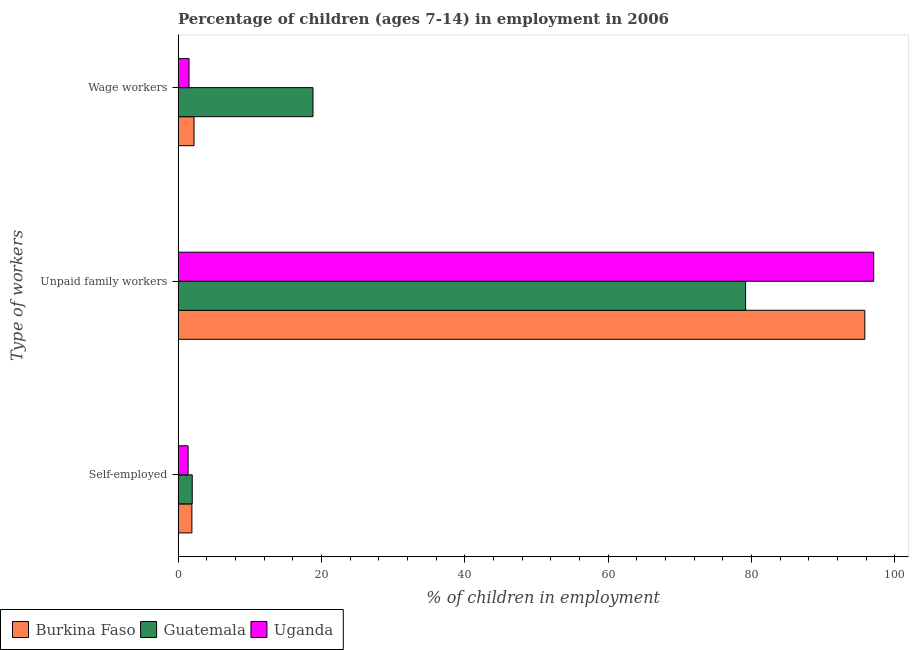How many different coloured bars are there?
Keep it short and to the point. 3. How many groups of bars are there?
Ensure brevity in your answer.  3. Are the number of bars per tick equal to the number of legend labels?
Your answer should be very brief. Yes. Are the number of bars on each tick of the Y-axis equal?
Your answer should be very brief. Yes. How many bars are there on the 2nd tick from the top?
Provide a succinct answer. 3. What is the label of the 1st group of bars from the top?
Give a very brief answer. Wage workers. What is the percentage of children employed as unpaid family workers in Uganda?
Ensure brevity in your answer.  97.07. Across all countries, what is the maximum percentage of children employed as unpaid family workers?
Give a very brief answer. 97.07. Across all countries, what is the minimum percentage of children employed as wage workers?
Provide a short and direct response. 1.53. In which country was the percentage of children employed as unpaid family workers maximum?
Offer a very short reply. Uganda. In which country was the percentage of children employed as unpaid family workers minimum?
Provide a succinct answer. Guatemala. What is the total percentage of children employed as unpaid family workers in the graph?
Make the answer very short. 272.09. What is the difference between the percentage of children employed as wage workers in Burkina Faso and that in Guatemala?
Your answer should be compact. -16.6. What is the difference between the percentage of self employed children in Uganda and the percentage of children employed as wage workers in Guatemala?
Offer a terse response. -17.43. What is the average percentage of self employed children per country?
Make the answer very short. 1.77. What is the difference between the percentage of self employed children and percentage of children employed as unpaid family workers in Uganda?
Keep it short and to the point. -95.67. What is the ratio of the percentage of children employed as wage workers in Burkina Faso to that in Guatemala?
Your response must be concise. 0.12. Is the percentage of self employed children in Uganda less than that in Guatemala?
Your answer should be very brief. Yes. What is the difference between the highest and the second highest percentage of self employed children?
Offer a very short reply. 0.05. What is the difference between the highest and the lowest percentage of children employed as wage workers?
Offer a very short reply. 17.3. In how many countries, is the percentage of self employed children greater than the average percentage of self employed children taken over all countries?
Your response must be concise. 2. Is the sum of the percentage of children employed as unpaid family workers in Uganda and Guatemala greater than the maximum percentage of self employed children across all countries?
Your answer should be very brief. Yes. What does the 3rd bar from the top in Unpaid family workers represents?
Offer a terse response. Burkina Faso. What does the 2nd bar from the bottom in Wage workers represents?
Your answer should be compact. Guatemala. How many bars are there?
Give a very brief answer. 9. Are all the bars in the graph horizontal?
Your answer should be very brief. Yes. How many countries are there in the graph?
Your response must be concise. 3. Does the graph contain any zero values?
Your answer should be compact. No. Does the graph contain grids?
Offer a very short reply. No. What is the title of the graph?
Ensure brevity in your answer.  Percentage of children (ages 7-14) in employment in 2006. Does "Niger" appear as one of the legend labels in the graph?
Your response must be concise. No. What is the label or title of the X-axis?
Make the answer very short. % of children in employment. What is the label or title of the Y-axis?
Provide a succinct answer. Type of workers. What is the % of children in employment in Burkina Faso in Self-employed?
Ensure brevity in your answer.  1.93. What is the % of children in employment in Guatemala in Self-employed?
Offer a very short reply. 1.98. What is the % of children in employment in Uganda in Self-employed?
Keep it short and to the point. 1.4. What is the % of children in employment in Burkina Faso in Unpaid family workers?
Your answer should be compact. 95.83. What is the % of children in employment of Guatemala in Unpaid family workers?
Your answer should be very brief. 79.19. What is the % of children in employment in Uganda in Unpaid family workers?
Make the answer very short. 97.07. What is the % of children in employment of Burkina Faso in Wage workers?
Your response must be concise. 2.23. What is the % of children in employment of Guatemala in Wage workers?
Your answer should be compact. 18.83. What is the % of children in employment in Uganda in Wage workers?
Your answer should be compact. 1.53. Across all Type of workers, what is the maximum % of children in employment of Burkina Faso?
Give a very brief answer. 95.83. Across all Type of workers, what is the maximum % of children in employment in Guatemala?
Your response must be concise. 79.19. Across all Type of workers, what is the maximum % of children in employment in Uganda?
Ensure brevity in your answer.  97.07. Across all Type of workers, what is the minimum % of children in employment in Burkina Faso?
Keep it short and to the point. 1.93. Across all Type of workers, what is the minimum % of children in employment of Guatemala?
Provide a succinct answer. 1.98. What is the total % of children in employment in Burkina Faso in the graph?
Give a very brief answer. 99.99. What is the total % of children in employment of Uganda in the graph?
Keep it short and to the point. 100. What is the difference between the % of children in employment of Burkina Faso in Self-employed and that in Unpaid family workers?
Provide a short and direct response. -93.9. What is the difference between the % of children in employment of Guatemala in Self-employed and that in Unpaid family workers?
Provide a succinct answer. -77.21. What is the difference between the % of children in employment of Uganda in Self-employed and that in Unpaid family workers?
Provide a short and direct response. -95.67. What is the difference between the % of children in employment in Burkina Faso in Self-employed and that in Wage workers?
Provide a succinct answer. -0.3. What is the difference between the % of children in employment of Guatemala in Self-employed and that in Wage workers?
Provide a succinct answer. -16.85. What is the difference between the % of children in employment in Uganda in Self-employed and that in Wage workers?
Provide a short and direct response. -0.13. What is the difference between the % of children in employment in Burkina Faso in Unpaid family workers and that in Wage workers?
Make the answer very short. 93.6. What is the difference between the % of children in employment of Guatemala in Unpaid family workers and that in Wage workers?
Give a very brief answer. 60.36. What is the difference between the % of children in employment of Uganda in Unpaid family workers and that in Wage workers?
Your response must be concise. 95.54. What is the difference between the % of children in employment of Burkina Faso in Self-employed and the % of children in employment of Guatemala in Unpaid family workers?
Ensure brevity in your answer.  -77.26. What is the difference between the % of children in employment in Burkina Faso in Self-employed and the % of children in employment in Uganda in Unpaid family workers?
Your answer should be very brief. -95.14. What is the difference between the % of children in employment in Guatemala in Self-employed and the % of children in employment in Uganda in Unpaid family workers?
Provide a succinct answer. -95.09. What is the difference between the % of children in employment of Burkina Faso in Self-employed and the % of children in employment of Guatemala in Wage workers?
Ensure brevity in your answer.  -16.9. What is the difference between the % of children in employment of Guatemala in Self-employed and the % of children in employment of Uganda in Wage workers?
Give a very brief answer. 0.45. What is the difference between the % of children in employment in Burkina Faso in Unpaid family workers and the % of children in employment in Guatemala in Wage workers?
Give a very brief answer. 77. What is the difference between the % of children in employment in Burkina Faso in Unpaid family workers and the % of children in employment in Uganda in Wage workers?
Provide a short and direct response. 94.3. What is the difference between the % of children in employment of Guatemala in Unpaid family workers and the % of children in employment of Uganda in Wage workers?
Provide a short and direct response. 77.66. What is the average % of children in employment of Burkina Faso per Type of workers?
Give a very brief answer. 33.33. What is the average % of children in employment in Guatemala per Type of workers?
Provide a short and direct response. 33.33. What is the average % of children in employment in Uganda per Type of workers?
Offer a terse response. 33.33. What is the difference between the % of children in employment in Burkina Faso and % of children in employment in Uganda in Self-employed?
Provide a succinct answer. 0.53. What is the difference between the % of children in employment in Guatemala and % of children in employment in Uganda in Self-employed?
Offer a very short reply. 0.58. What is the difference between the % of children in employment of Burkina Faso and % of children in employment of Guatemala in Unpaid family workers?
Give a very brief answer. 16.64. What is the difference between the % of children in employment in Burkina Faso and % of children in employment in Uganda in Unpaid family workers?
Provide a short and direct response. -1.24. What is the difference between the % of children in employment in Guatemala and % of children in employment in Uganda in Unpaid family workers?
Ensure brevity in your answer.  -17.88. What is the difference between the % of children in employment in Burkina Faso and % of children in employment in Guatemala in Wage workers?
Your answer should be compact. -16.6. What is the ratio of the % of children in employment of Burkina Faso in Self-employed to that in Unpaid family workers?
Provide a short and direct response. 0.02. What is the ratio of the % of children in employment of Guatemala in Self-employed to that in Unpaid family workers?
Provide a short and direct response. 0.03. What is the ratio of the % of children in employment in Uganda in Self-employed to that in Unpaid family workers?
Keep it short and to the point. 0.01. What is the ratio of the % of children in employment of Burkina Faso in Self-employed to that in Wage workers?
Provide a short and direct response. 0.87. What is the ratio of the % of children in employment of Guatemala in Self-employed to that in Wage workers?
Make the answer very short. 0.11. What is the ratio of the % of children in employment of Uganda in Self-employed to that in Wage workers?
Your answer should be compact. 0.92. What is the ratio of the % of children in employment in Burkina Faso in Unpaid family workers to that in Wage workers?
Ensure brevity in your answer.  42.97. What is the ratio of the % of children in employment in Guatemala in Unpaid family workers to that in Wage workers?
Your response must be concise. 4.21. What is the ratio of the % of children in employment of Uganda in Unpaid family workers to that in Wage workers?
Make the answer very short. 63.44. What is the difference between the highest and the second highest % of children in employment of Burkina Faso?
Give a very brief answer. 93.6. What is the difference between the highest and the second highest % of children in employment of Guatemala?
Offer a very short reply. 60.36. What is the difference between the highest and the second highest % of children in employment in Uganda?
Provide a short and direct response. 95.54. What is the difference between the highest and the lowest % of children in employment in Burkina Faso?
Make the answer very short. 93.9. What is the difference between the highest and the lowest % of children in employment of Guatemala?
Your answer should be compact. 77.21. What is the difference between the highest and the lowest % of children in employment in Uganda?
Your response must be concise. 95.67. 